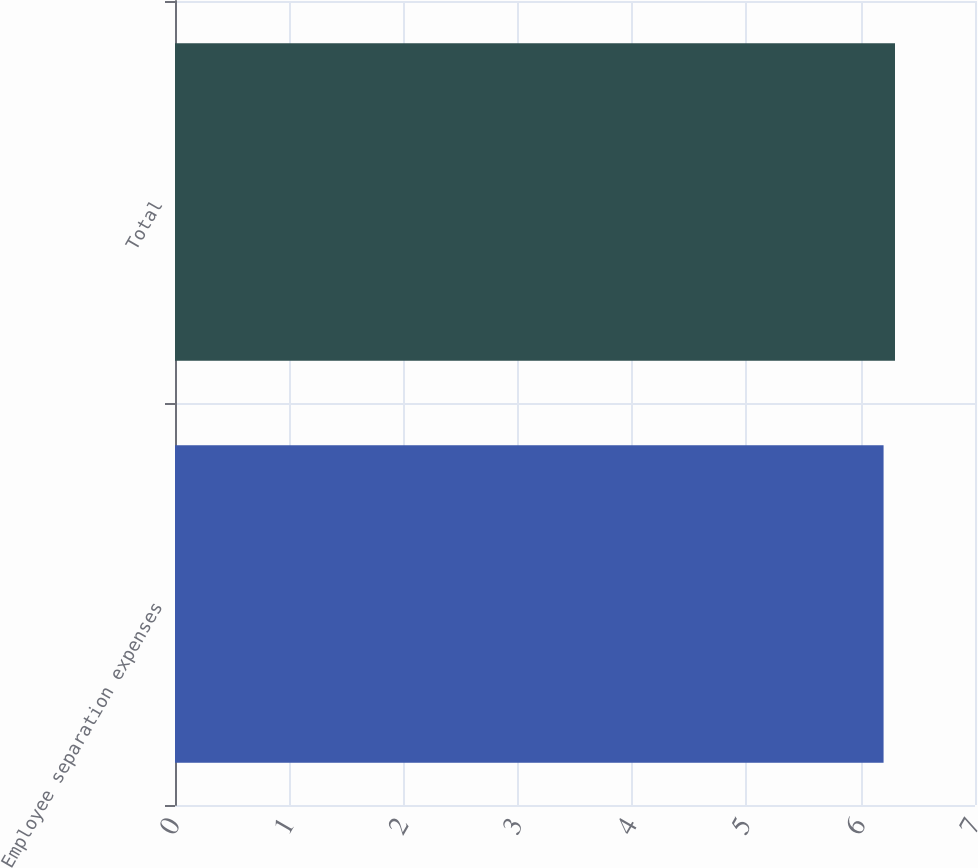Convert chart to OTSL. <chart><loc_0><loc_0><loc_500><loc_500><bar_chart><fcel>Employee separation expenses<fcel>Total<nl><fcel>6.2<fcel>6.3<nl></chart> 